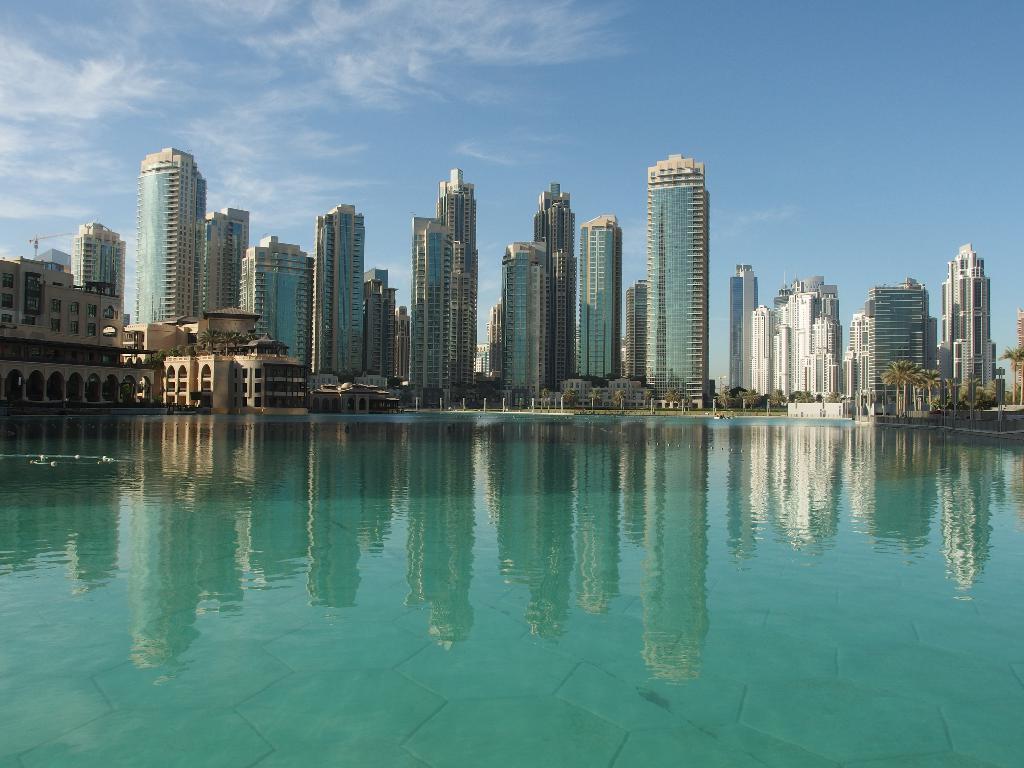How would you summarize this image in a sentence or two? In this image we can see a lake. In the middle of the image buildings, poles and trees are there. At the top of the image sky is there with little clouds. 